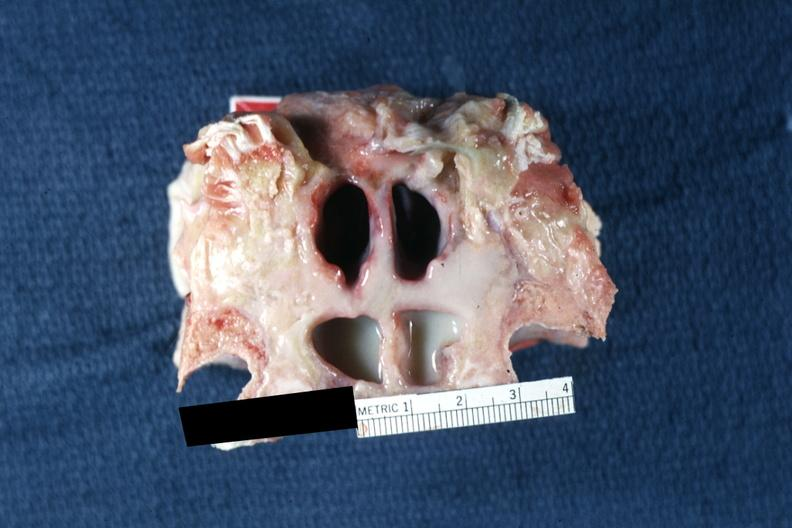what does this image show?
Answer the question using a single word or phrase. Frontal sinuses inflammation and pus well shown 